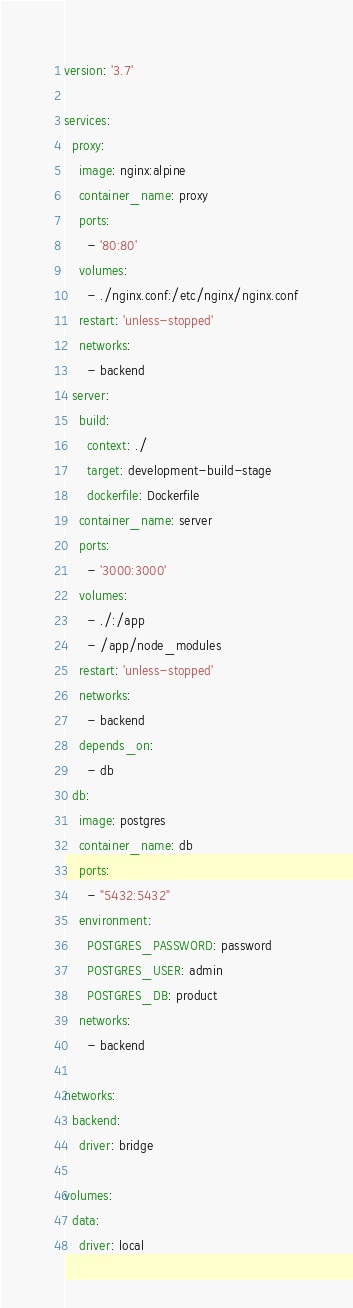<code> <loc_0><loc_0><loc_500><loc_500><_YAML_>version: '3.7'

services:
  proxy:
    image: nginx:alpine
    container_name: proxy
    ports:
      - '80:80'
    volumes:
      - ./nginx.conf:/etc/nginx/nginx.conf
    restart: 'unless-stopped'
    networks:
      - backend
  server:
    build:
      context: ./
      target: development-build-stage
      dockerfile: Dockerfile
    container_name: server
    ports:
      - '3000:3000'
    volumes:
      - ./:/app
      - /app/node_modules
    restart: 'unless-stopped'
    networks:
      - backend
    depends_on:
      - db
  db:
    image: postgres
    container_name: db
    ports:
      - "5432:5432"
    environment:
      POSTGRES_PASSWORD: password
      POSTGRES_USER: admin
      POSTGRES_DB: product
    networks:
      - backend

networks:
  backend:
    driver: bridge

volumes:
  data:
    driver: local
</code> 